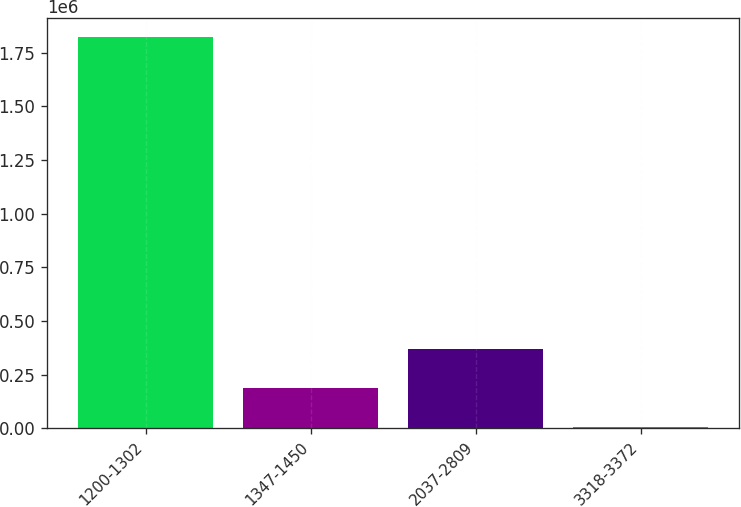<chart> <loc_0><loc_0><loc_500><loc_500><bar_chart><fcel>1200-1302<fcel>1347-1450<fcel>2037-2809<fcel>3318-3372<nl><fcel>1.8206e+06<fcel>185917<fcel>367548<fcel>4286<nl></chart> 